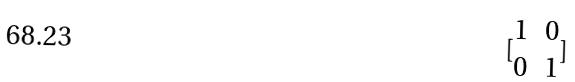<formula> <loc_0><loc_0><loc_500><loc_500>[ \begin{matrix} 1 & 0 \\ 0 & 1 \end{matrix} ]</formula> 